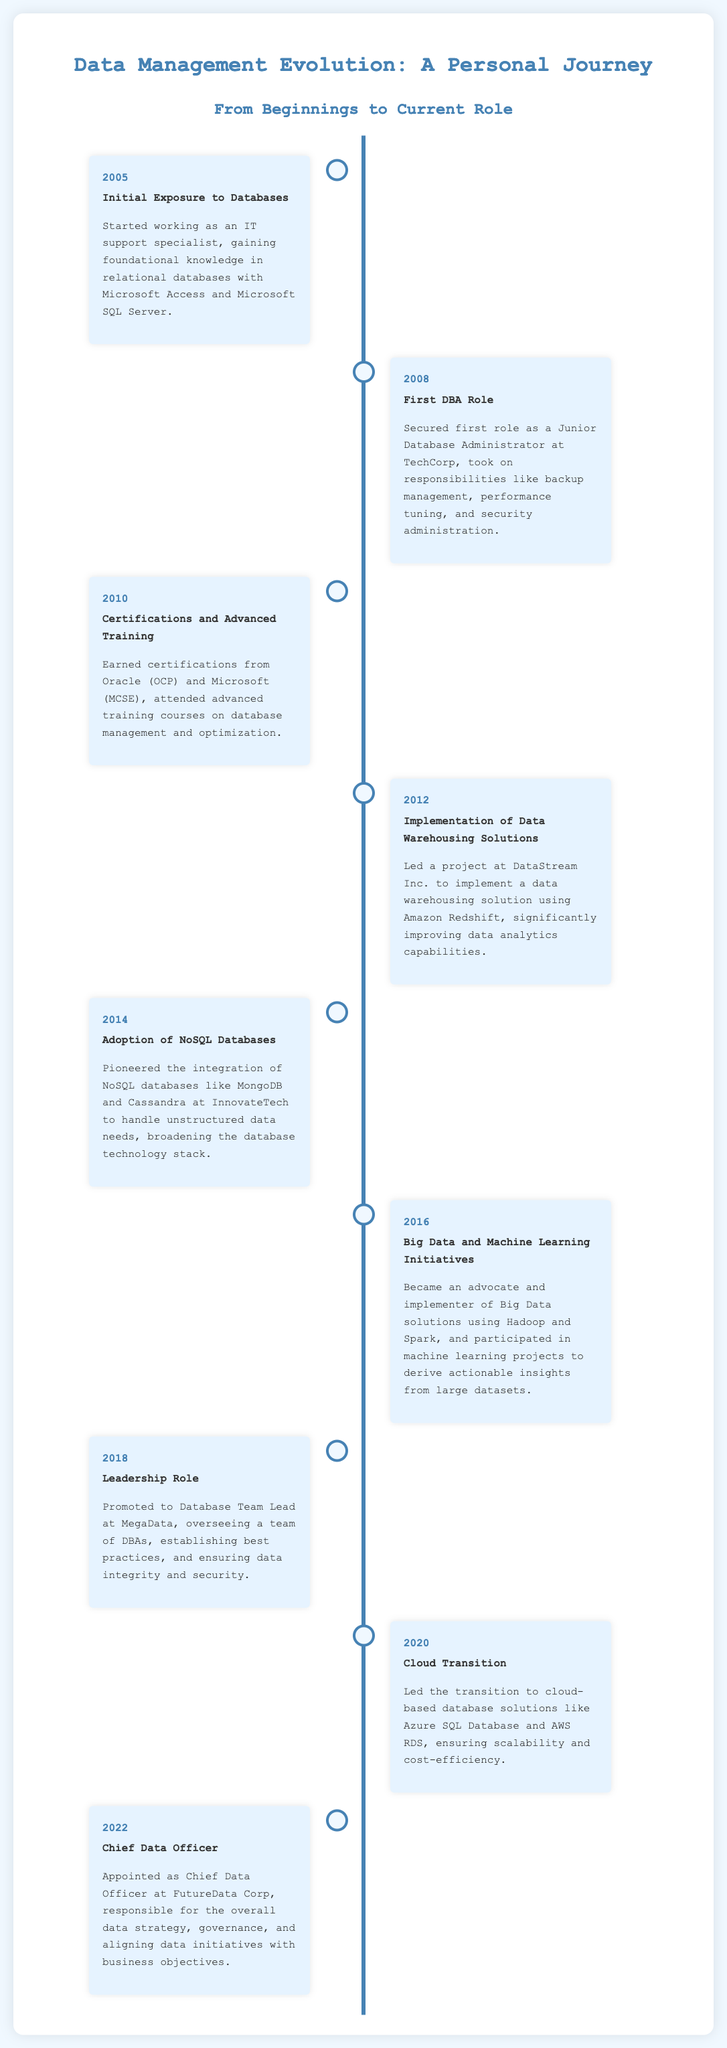What year marked the initial exposure to databases? The document states that the initial exposure to databases occurred in 2005.
Answer: 2005 What role was secured in 2008? The timeline details that the first role as a Junior Database Administrator was secured in 2008.
Answer: Junior Database Administrator Which certifications were earned in 2010? The document mentions that certifications from Oracle (OCP) and Microsoft (MCSE) were earned in 2010.
Answer: Oracle (OCP) and Microsoft (MCSE) What major database solution was implemented in 2012? According to the document, a data warehousing solution using Amazon Redshift was implemented in 2012.
Answer: data warehousing solution using Amazon Redshift In what year did the transition to cloud-based database solutions occur? The timeline indicates that the transition to cloud-based database solutions occurred in 2020.
Answer: 2020 Which position was held in 2022? The document states that the position of Chief Data Officer was held in 2022.
Answer: Chief Data Officer What technology was adopted in 2014 to handle unstructured data? The timeline notes the integration of NoSQL databases like MongoDB and Cassandra in 2014.
Answer: NoSQL databases like MongoDB and Cassandra What was a key focus in the 2016 initiatives? The document outlines that Big Data and Machine Learning initiatives were a key focus in 2016.
Answer: Big Data and Machine Learning What was the primary responsibility of the Chief Data Officer? The document specifies that the Chief Data Officer was responsible for the overall data strategy and governance.
Answer: overall data strategy and governance 